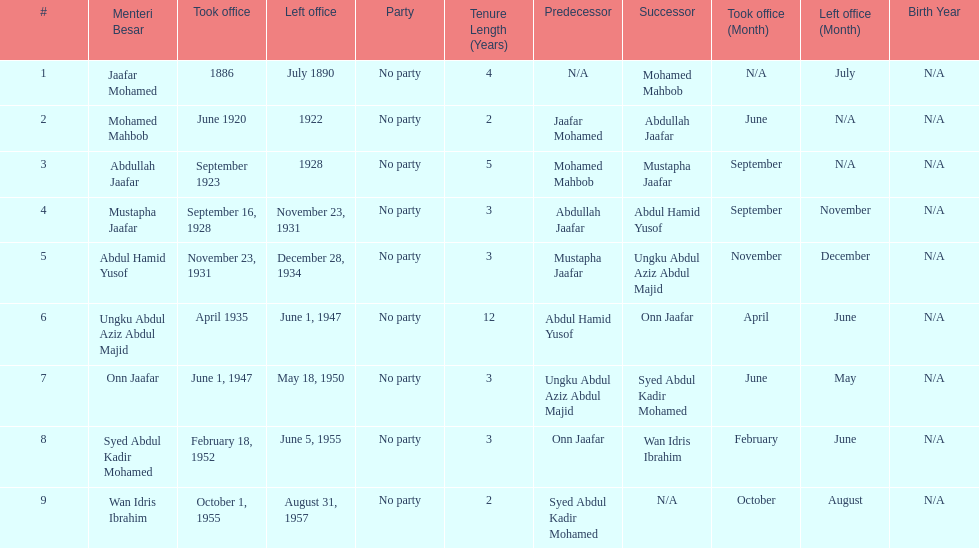Other than abullah jaafar, name someone with the same last name. Mustapha Jaafar. 